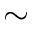Convert formula to latex. <formula><loc_0><loc_0><loc_500><loc_500>\sim</formula> 